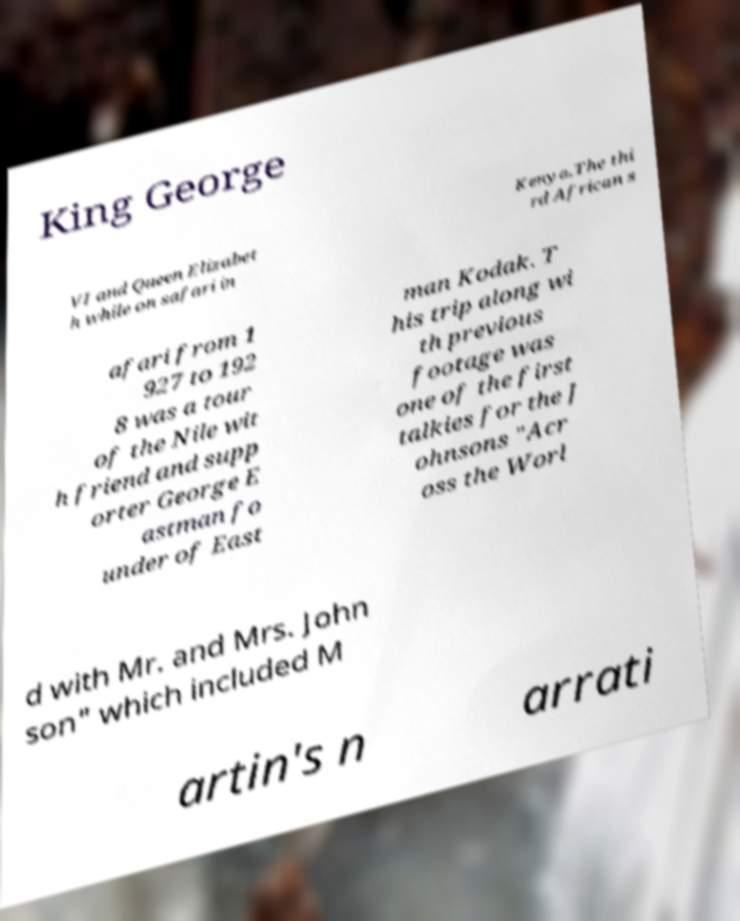Can you read and provide the text displayed in the image?This photo seems to have some interesting text. Can you extract and type it out for me? King George VI and Queen Elizabet h while on safari in Kenya.The thi rd African s afari from 1 927 to 192 8 was a tour of the Nile wit h friend and supp orter George E astman fo under of East man Kodak. T his trip along wi th previous footage was one of the first talkies for the J ohnsons "Acr oss the Worl d with Mr. and Mrs. John son" which included M artin's n arrati 